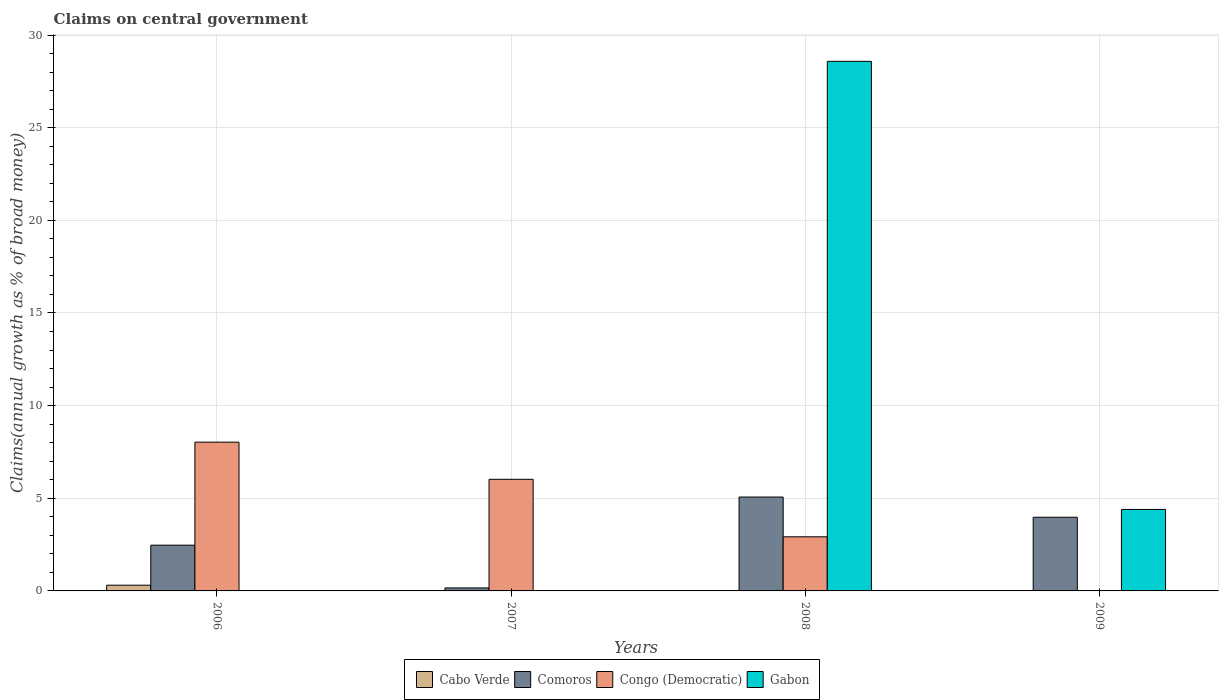How many different coloured bars are there?
Keep it short and to the point. 4. Are the number of bars per tick equal to the number of legend labels?
Your answer should be compact. No. How many bars are there on the 2nd tick from the right?
Make the answer very short. 3. In how many cases, is the number of bars for a given year not equal to the number of legend labels?
Make the answer very short. 4. What is the percentage of broad money claimed on centeral government in Cabo Verde in 2009?
Your answer should be very brief. 0. Across all years, what is the maximum percentage of broad money claimed on centeral government in Cabo Verde?
Your answer should be very brief. 0.31. Across all years, what is the minimum percentage of broad money claimed on centeral government in Cabo Verde?
Your response must be concise. 0. What is the total percentage of broad money claimed on centeral government in Congo (Democratic) in the graph?
Provide a short and direct response. 16.97. What is the difference between the percentage of broad money claimed on centeral government in Comoros in 2007 and that in 2008?
Provide a short and direct response. -4.91. What is the difference between the percentage of broad money claimed on centeral government in Cabo Verde in 2008 and the percentage of broad money claimed on centeral government in Comoros in 2007?
Your answer should be compact. -0.16. What is the average percentage of broad money claimed on centeral government in Congo (Democratic) per year?
Ensure brevity in your answer.  4.24. In the year 2009, what is the difference between the percentage of broad money claimed on centeral government in Comoros and percentage of broad money claimed on centeral government in Gabon?
Offer a very short reply. -0.42. In how many years, is the percentage of broad money claimed on centeral government in Cabo Verde greater than 11 %?
Provide a succinct answer. 0. What is the ratio of the percentage of broad money claimed on centeral government in Comoros in 2006 to that in 2007?
Ensure brevity in your answer.  15.27. What is the difference between the highest and the second highest percentage of broad money claimed on centeral government in Congo (Democratic)?
Offer a very short reply. 2. What is the difference between the highest and the lowest percentage of broad money claimed on centeral government in Congo (Democratic)?
Your answer should be very brief. 8.03. In how many years, is the percentage of broad money claimed on centeral government in Congo (Democratic) greater than the average percentage of broad money claimed on centeral government in Congo (Democratic) taken over all years?
Your answer should be very brief. 2. How many bars are there?
Your answer should be compact. 10. Are all the bars in the graph horizontal?
Ensure brevity in your answer.  No. What is the difference between two consecutive major ticks on the Y-axis?
Offer a terse response. 5. Does the graph contain grids?
Ensure brevity in your answer.  Yes. Where does the legend appear in the graph?
Provide a succinct answer. Bottom center. What is the title of the graph?
Your answer should be compact. Claims on central government. Does "Netherlands" appear as one of the legend labels in the graph?
Your response must be concise. No. What is the label or title of the Y-axis?
Offer a terse response. Claims(annual growth as % of broad money). What is the Claims(annual growth as % of broad money) in Cabo Verde in 2006?
Make the answer very short. 0.31. What is the Claims(annual growth as % of broad money) of Comoros in 2006?
Offer a very short reply. 2.47. What is the Claims(annual growth as % of broad money) of Congo (Democratic) in 2006?
Your response must be concise. 8.03. What is the Claims(annual growth as % of broad money) of Gabon in 2006?
Your answer should be very brief. 0. What is the Claims(annual growth as % of broad money) in Cabo Verde in 2007?
Provide a succinct answer. 0. What is the Claims(annual growth as % of broad money) in Comoros in 2007?
Provide a succinct answer. 0.16. What is the Claims(annual growth as % of broad money) of Congo (Democratic) in 2007?
Give a very brief answer. 6.02. What is the Claims(annual growth as % of broad money) in Cabo Verde in 2008?
Provide a short and direct response. 0. What is the Claims(annual growth as % of broad money) of Comoros in 2008?
Your response must be concise. 5.07. What is the Claims(annual growth as % of broad money) of Congo (Democratic) in 2008?
Give a very brief answer. 2.92. What is the Claims(annual growth as % of broad money) of Gabon in 2008?
Make the answer very short. 28.58. What is the Claims(annual growth as % of broad money) of Comoros in 2009?
Your answer should be compact. 3.98. What is the Claims(annual growth as % of broad money) of Congo (Democratic) in 2009?
Give a very brief answer. 0. What is the Claims(annual growth as % of broad money) in Gabon in 2009?
Your answer should be very brief. 4.4. Across all years, what is the maximum Claims(annual growth as % of broad money) of Cabo Verde?
Your answer should be compact. 0.31. Across all years, what is the maximum Claims(annual growth as % of broad money) of Comoros?
Provide a succinct answer. 5.07. Across all years, what is the maximum Claims(annual growth as % of broad money) of Congo (Democratic)?
Provide a short and direct response. 8.03. Across all years, what is the maximum Claims(annual growth as % of broad money) of Gabon?
Keep it short and to the point. 28.58. Across all years, what is the minimum Claims(annual growth as % of broad money) of Cabo Verde?
Offer a terse response. 0. Across all years, what is the minimum Claims(annual growth as % of broad money) in Comoros?
Provide a short and direct response. 0.16. Across all years, what is the minimum Claims(annual growth as % of broad money) of Congo (Democratic)?
Provide a short and direct response. 0. Across all years, what is the minimum Claims(annual growth as % of broad money) in Gabon?
Make the answer very short. 0. What is the total Claims(annual growth as % of broad money) of Cabo Verde in the graph?
Your answer should be compact. 0.31. What is the total Claims(annual growth as % of broad money) in Comoros in the graph?
Your response must be concise. 11.67. What is the total Claims(annual growth as % of broad money) in Congo (Democratic) in the graph?
Offer a very short reply. 16.97. What is the total Claims(annual growth as % of broad money) of Gabon in the graph?
Your answer should be very brief. 32.98. What is the difference between the Claims(annual growth as % of broad money) in Comoros in 2006 and that in 2007?
Offer a terse response. 2.31. What is the difference between the Claims(annual growth as % of broad money) of Congo (Democratic) in 2006 and that in 2007?
Your answer should be very brief. 2. What is the difference between the Claims(annual growth as % of broad money) in Comoros in 2006 and that in 2008?
Provide a succinct answer. -2.6. What is the difference between the Claims(annual growth as % of broad money) in Congo (Democratic) in 2006 and that in 2008?
Your answer should be very brief. 5.11. What is the difference between the Claims(annual growth as % of broad money) in Comoros in 2006 and that in 2009?
Give a very brief answer. -1.51. What is the difference between the Claims(annual growth as % of broad money) of Comoros in 2007 and that in 2008?
Your answer should be compact. -4.91. What is the difference between the Claims(annual growth as % of broad money) in Congo (Democratic) in 2007 and that in 2008?
Offer a terse response. 3.1. What is the difference between the Claims(annual growth as % of broad money) of Comoros in 2007 and that in 2009?
Offer a terse response. -3.81. What is the difference between the Claims(annual growth as % of broad money) in Comoros in 2008 and that in 2009?
Offer a terse response. 1.09. What is the difference between the Claims(annual growth as % of broad money) in Gabon in 2008 and that in 2009?
Your response must be concise. 24.18. What is the difference between the Claims(annual growth as % of broad money) in Cabo Verde in 2006 and the Claims(annual growth as % of broad money) in Comoros in 2007?
Offer a very short reply. 0.15. What is the difference between the Claims(annual growth as % of broad money) in Cabo Verde in 2006 and the Claims(annual growth as % of broad money) in Congo (Democratic) in 2007?
Offer a terse response. -5.71. What is the difference between the Claims(annual growth as % of broad money) of Comoros in 2006 and the Claims(annual growth as % of broad money) of Congo (Democratic) in 2007?
Keep it short and to the point. -3.55. What is the difference between the Claims(annual growth as % of broad money) of Cabo Verde in 2006 and the Claims(annual growth as % of broad money) of Comoros in 2008?
Ensure brevity in your answer.  -4.76. What is the difference between the Claims(annual growth as % of broad money) of Cabo Verde in 2006 and the Claims(annual growth as % of broad money) of Congo (Democratic) in 2008?
Provide a short and direct response. -2.61. What is the difference between the Claims(annual growth as % of broad money) in Cabo Verde in 2006 and the Claims(annual growth as % of broad money) in Gabon in 2008?
Offer a very short reply. -28.27. What is the difference between the Claims(annual growth as % of broad money) of Comoros in 2006 and the Claims(annual growth as % of broad money) of Congo (Democratic) in 2008?
Ensure brevity in your answer.  -0.45. What is the difference between the Claims(annual growth as % of broad money) in Comoros in 2006 and the Claims(annual growth as % of broad money) in Gabon in 2008?
Ensure brevity in your answer.  -26.11. What is the difference between the Claims(annual growth as % of broad money) of Congo (Democratic) in 2006 and the Claims(annual growth as % of broad money) of Gabon in 2008?
Give a very brief answer. -20.55. What is the difference between the Claims(annual growth as % of broad money) of Cabo Verde in 2006 and the Claims(annual growth as % of broad money) of Comoros in 2009?
Make the answer very short. -3.67. What is the difference between the Claims(annual growth as % of broad money) in Cabo Verde in 2006 and the Claims(annual growth as % of broad money) in Gabon in 2009?
Make the answer very short. -4.09. What is the difference between the Claims(annual growth as % of broad money) in Comoros in 2006 and the Claims(annual growth as % of broad money) in Gabon in 2009?
Ensure brevity in your answer.  -1.93. What is the difference between the Claims(annual growth as % of broad money) in Congo (Democratic) in 2006 and the Claims(annual growth as % of broad money) in Gabon in 2009?
Your answer should be compact. 3.63. What is the difference between the Claims(annual growth as % of broad money) of Comoros in 2007 and the Claims(annual growth as % of broad money) of Congo (Democratic) in 2008?
Provide a succinct answer. -2.76. What is the difference between the Claims(annual growth as % of broad money) in Comoros in 2007 and the Claims(annual growth as % of broad money) in Gabon in 2008?
Offer a terse response. -28.42. What is the difference between the Claims(annual growth as % of broad money) of Congo (Democratic) in 2007 and the Claims(annual growth as % of broad money) of Gabon in 2008?
Provide a succinct answer. -22.56. What is the difference between the Claims(annual growth as % of broad money) of Comoros in 2007 and the Claims(annual growth as % of broad money) of Gabon in 2009?
Your response must be concise. -4.24. What is the difference between the Claims(annual growth as % of broad money) in Congo (Democratic) in 2007 and the Claims(annual growth as % of broad money) in Gabon in 2009?
Keep it short and to the point. 1.63. What is the difference between the Claims(annual growth as % of broad money) in Comoros in 2008 and the Claims(annual growth as % of broad money) in Gabon in 2009?
Your response must be concise. 0.67. What is the difference between the Claims(annual growth as % of broad money) of Congo (Democratic) in 2008 and the Claims(annual growth as % of broad money) of Gabon in 2009?
Your answer should be compact. -1.48. What is the average Claims(annual growth as % of broad money) of Cabo Verde per year?
Your answer should be compact. 0.08. What is the average Claims(annual growth as % of broad money) of Comoros per year?
Keep it short and to the point. 2.92. What is the average Claims(annual growth as % of broad money) in Congo (Democratic) per year?
Keep it short and to the point. 4.24. What is the average Claims(annual growth as % of broad money) in Gabon per year?
Give a very brief answer. 8.24. In the year 2006, what is the difference between the Claims(annual growth as % of broad money) in Cabo Verde and Claims(annual growth as % of broad money) in Comoros?
Keep it short and to the point. -2.16. In the year 2006, what is the difference between the Claims(annual growth as % of broad money) in Cabo Verde and Claims(annual growth as % of broad money) in Congo (Democratic)?
Offer a very short reply. -7.72. In the year 2006, what is the difference between the Claims(annual growth as % of broad money) of Comoros and Claims(annual growth as % of broad money) of Congo (Democratic)?
Give a very brief answer. -5.56. In the year 2007, what is the difference between the Claims(annual growth as % of broad money) in Comoros and Claims(annual growth as % of broad money) in Congo (Democratic)?
Offer a terse response. -5.86. In the year 2008, what is the difference between the Claims(annual growth as % of broad money) in Comoros and Claims(annual growth as % of broad money) in Congo (Democratic)?
Offer a terse response. 2.15. In the year 2008, what is the difference between the Claims(annual growth as % of broad money) of Comoros and Claims(annual growth as % of broad money) of Gabon?
Offer a very short reply. -23.51. In the year 2008, what is the difference between the Claims(annual growth as % of broad money) of Congo (Democratic) and Claims(annual growth as % of broad money) of Gabon?
Offer a very short reply. -25.66. In the year 2009, what is the difference between the Claims(annual growth as % of broad money) in Comoros and Claims(annual growth as % of broad money) in Gabon?
Provide a short and direct response. -0.42. What is the ratio of the Claims(annual growth as % of broad money) of Comoros in 2006 to that in 2007?
Give a very brief answer. 15.27. What is the ratio of the Claims(annual growth as % of broad money) of Congo (Democratic) in 2006 to that in 2007?
Give a very brief answer. 1.33. What is the ratio of the Claims(annual growth as % of broad money) in Comoros in 2006 to that in 2008?
Your response must be concise. 0.49. What is the ratio of the Claims(annual growth as % of broad money) in Congo (Democratic) in 2006 to that in 2008?
Your response must be concise. 2.75. What is the ratio of the Claims(annual growth as % of broad money) of Comoros in 2006 to that in 2009?
Give a very brief answer. 0.62. What is the ratio of the Claims(annual growth as % of broad money) in Comoros in 2007 to that in 2008?
Provide a short and direct response. 0.03. What is the ratio of the Claims(annual growth as % of broad money) in Congo (Democratic) in 2007 to that in 2008?
Your response must be concise. 2.06. What is the ratio of the Claims(annual growth as % of broad money) of Comoros in 2007 to that in 2009?
Keep it short and to the point. 0.04. What is the ratio of the Claims(annual growth as % of broad money) in Comoros in 2008 to that in 2009?
Your answer should be compact. 1.27. What is the ratio of the Claims(annual growth as % of broad money) of Gabon in 2008 to that in 2009?
Offer a terse response. 6.5. What is the difference between the highest and the second highest Claims(annual growth as % of broad money) in Comoros?
Your answer should be compact. 1.09. What is the difference between the highest and the second highest Claims(annual growth as % of broad money) in Congo (Democratic)?
Provide a short and direct response. 2. What is the difference between the highest and the lowest Claims(annual growth as % of broad money) of Cabo Verde?
Make the answer very short. 0.31. What is the difference between the highest and the lowest Claims(annual growth as % of broad money) of Comoros?
Give a very brief answer. 4.91. What is the difference between the highest and the lowest Claims(annual growth as % of broad money) of Congo (Democratic)?
Your answer should be very brief. 8.03. What is the difference between the highest and the lowest Claims(annual growth as % of broad money) of Gabon?
Provide a succinct answer. 28.58. 